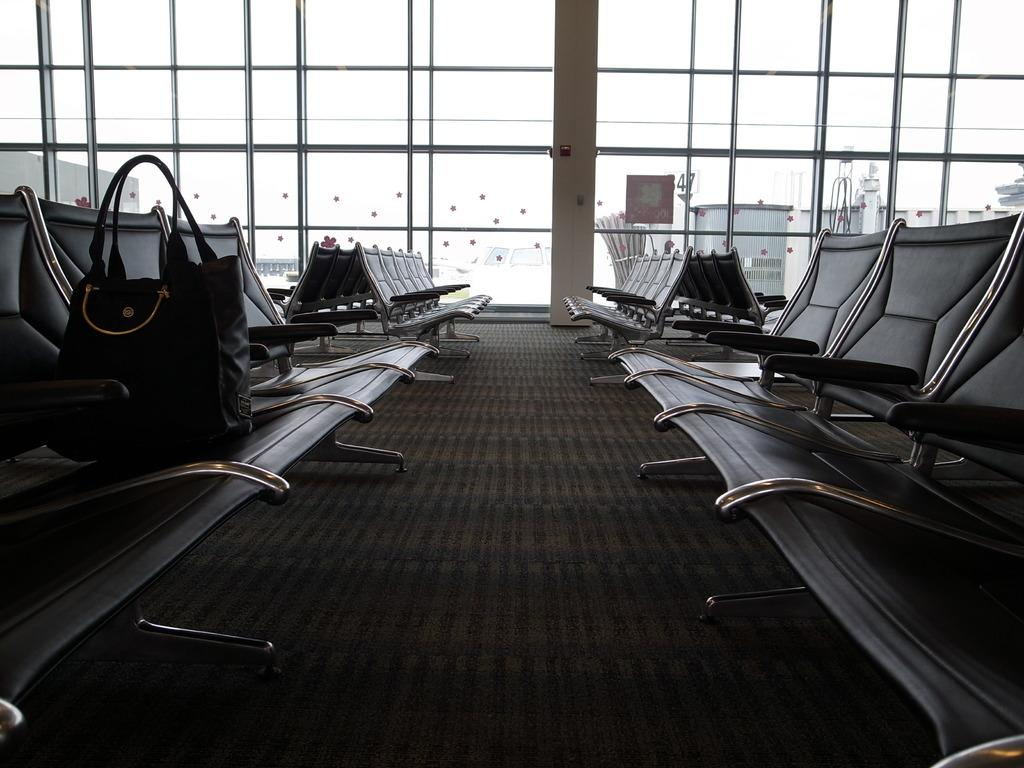What object is placed on the chair in the left side of the image? There is a handbag on a chair in the left side of the image. What are the chairs in the image used for? The chairs in the image are for visitors. What type of architectural feature can be seen in the middle of the image? There is a glass window in the middle of the image. What is visible on one side of the image? There is a wall visible in the image. How many bombs can be seen in the image? There are no bombs present in the image. Can you tell me how many copies of the handbag are visible in the image? There is only one handbag visible in the image, so there are no copies. 